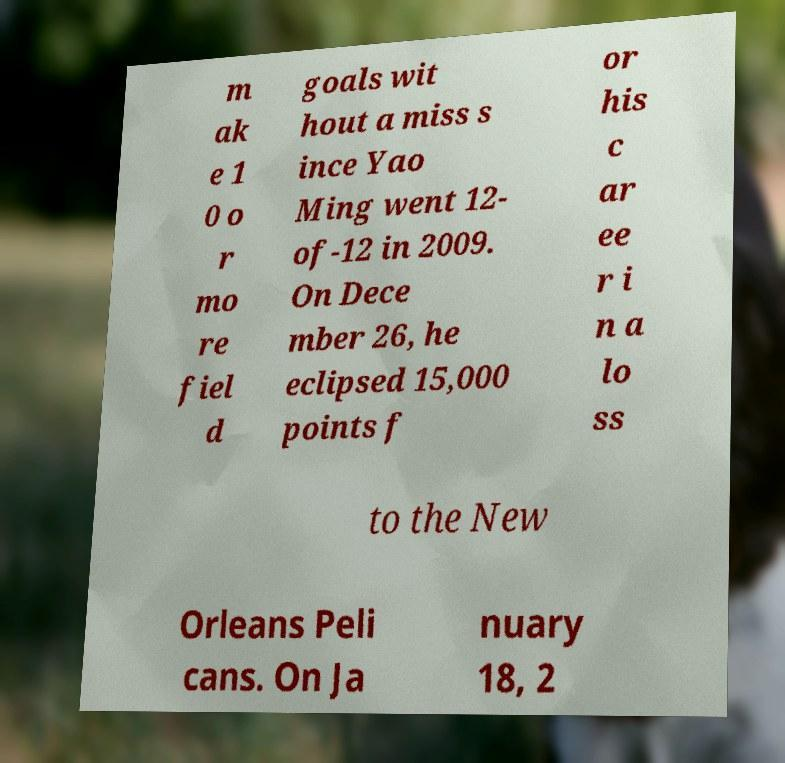Can you read and provide the text displayed in the image?This photo seems to have some interesting text. Can you extract and type it out for me? m ak e 1 0 o r mo re fiel d goals wit hout a miss s ince Yao Ming went 12- of-12 in 2009. On Dece mber 26, he eclipsed 15,000 points f or his c ar ee r i n a lo ss to the New Orleans Peli cans. On Ja nuary 18, 2 